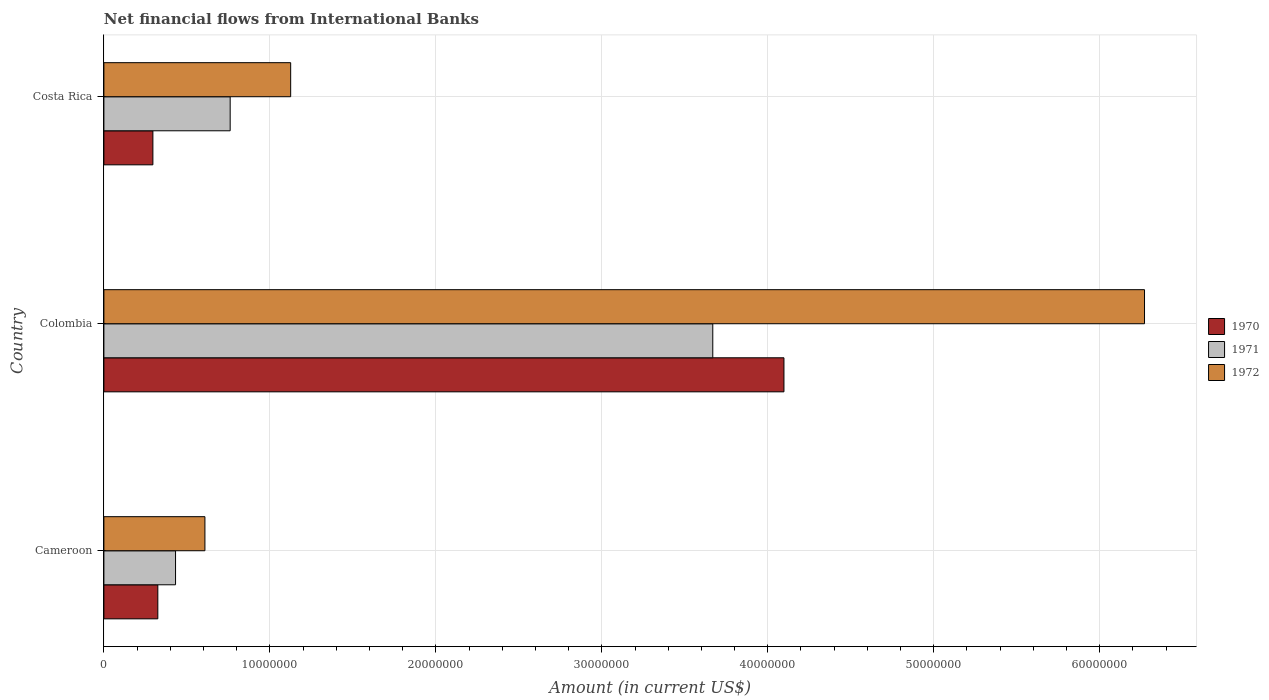How many different coloured bars are there?
Offer a terse response. 3. Are the number of bars per tick equal to the number of legend labels?
Make the answer very short. Yes. How many bars are there on the 3rd tick from the bottom?
Your response must be concise. 3. In how many cases, is the number of bars for a given country not equal to the number of legend labels?
Keep it short and to the point. 0. What is the net financial aid flows in 1972 in Cameroon?
Your answer should be compact. 6.09e+06. Across all countries, what is the maximum net financial aid flows in 1970?
Your answer should be very brief. 4.10e+07. Across all countries, what is the minimum net financial aid flows in 1972?
Your answer should be very brief. 6.09e+06. In which country was the net financial aid flows in 1970 maximum?
Your response must be concise. Colombia. In which country was the net financial aid flows in 1972 minimum?
Provide a succinct answer. Cameroon. What is the total net financial aid flows in 1971 in the graph?
Make the answer very short. 4.86e+07. What is the difference between the net financial aid flows in 1972 in Cameroon and that in Costa Rica?
Your response must be concise. -5.17e+06. What is the difference between the net financial aid flows in 1970 in Costa Rica and the net financial aid flows in 1971 in Colombia?
Give a very brief answer. -3.37e+07. What is the average net financial aid flows in 1972 per country?
Ensure brevity in your answer.  2.67e+07. What is the difference between the net financial aid flows in 1971 and net financial aid flows in 1972 in Costa Rica?
Ensure brevity in your answer.  -3.64e+06. What is the ratio of the net financial aid flows in 1970 in Colombia to that in Costa Rica?
Provide a succinct answer. 13.88. Is the net financial aid flows in 1971 in Colombia less than that in Costa Rica?
Keep it short and to the point. No. What is the difference between the highest and the second highest net financial aid flows in 1972?
Offer a terse response. 5.14e+07. What is the difference between the highest and the lowest net financial aid flows in 1971?
Offer a very short reply. 3.24e+07. In how many countries, is the net financial aid flows in 1972 greater than the average net financial aid flows in 1972 taken over all countries?
Give a very brief answer. 1. Is the sum of the net financial aid flows in 1972 in Cameroon and Costa Rica greater than the maximum net financial aid flows in 1971 across all countries?
Your response must be concise. No. How many bars are there?
Ensure brevity in your answer.  9. Are all the bars in the graph horizontal?
Provide a succinct answer. Yes. What is the difference between two consecutive major ticks on the X-axis?
Give a very brief answer. 1.00e+07. Are the values on the major ticks of X-axis written in scientific E-notation?
Give a very brief answer. No. Does the graph contain any zero values?
Your response must be concise. No. Does the graph contain grids?
Provide a succinct answer. Yes. What is the title of the graph?
Provide a succinct answer. Net financial flows from International Banks. What is the label or title of the X-axis?
Provide a succinct answer. Amount (in current US$). What is the label or title of the Y-axis?
Your answer should be very brief. Country. What is the Amount (in current US$) in 1970 in Cameroon?
Your response must be concise. 3.25e+06. What is the Amount (in current US$) in 1971 in Cameroon?
Make the answer very short. 4.32e+06. What is the Amount (in current US$) in 1972 in Cameroon?
Give a very brief answer. 6.09e+06. What is the Amount (in current US$) in 1970 in Colombia?
Offer a very short reply. 4.10e+07. What is the Amount (in current US$) in 1971 in Colombia?
Give a very brief answer. 3.67e+07. What is the Amount (in current US$) of 1972 in Colombia?
Provide a short and direct response. 6.27e+07. What is the Amount (in current US$) of 1970 in Costa Rica?
Your answer should be very brief. 2.95e+06. What is the Amount (in current US$) of 1971 in Costa Rica?
Keep it short and to the point. 7.61e+06. What is the Amount (in current US$) in 1972 in Costa Rica?
Keep it short and to the point. 1.13e+07. Across all countries, what is the maximum Amount (in current US$) of 1970?
Offer a terse response. 4.10e+07. Across all countries, what is the maximum Amount (in current US$) of 1971?
Offer a terse response. 3.67e+07. Across all countries, what is the maximum Amount (in current US$) of 1972?
Offer a very short reply. 6.27e+07. Across all countries, what is the minimum Amount (in current US$) in 1970?
Provide a succinct answer. 2.95e+06. Across all countries, what is the minimum Amount (in current US$) in 1971?
Give a very brief answer. 4.32e+06. Across all countries, what is the minimum Amount (in current US$) in 1972?
Your response must be concise. 6.09e+06. What is the total Amount (in current US$) of 1970 in the graph?
Your response must be concise. 4.72e+07. What is the total Amount (in current US$) in 1971 in the graph?
Ensure brevity in your answer.  4.86e+07. What is the total Amount (in current US$) in 1972 in the graph?
Give a very brief answer. 8.00e+07. What is the difference between the Amount (in current US$) of 1970 in Cameroon and that in Colombia?
Your answer should be compact. -3.77e+07. What is the difference between the Amount (in current US$) of 1971 in Cameroon and that in Colombia?
Your response must be concise. -3.24e+07. What is the difference between the Amount (in current US$) in 1972 in Cameroon and that in Colombia?
Ensure brevity in your answer.  -5.66e+07. What is the difference between the Amount (in current US$) in 1970 in Cameroon and that in Costa Rica?
Keep it short and to the point. 2.98e+05. What is the difference between the Amount (in current US$) of 1971 in Cameroon and that in Costa Rica?
Provide a succinct answer. -3.29e+06. What is the difference between the Amount (in current US$) of 1972 in Cameroon and that in Costa Rica?
Provide a succinct answer. -5.17e+06. What is the difference between the Amount (in current US$) in 1970 in Colombia and that in Costa Rica?
Provide a short and direct response. 3.80e+07. What is the difference between the Amount (in current US$) of 1971 in Colombia and that in Costa Rica?
Your answer should be compact. 2.91e+07. What is the difference between the Amount (in current US$) of 1972 in Colombia and that in Costa Rica?
Keep it short and to the point. 5.14e+07. What is the difference between the Amount (in current US$) of 1970 in Cameroon and the Amount (in current US$) of 1971 in Colombia?
Make the answer very short. -3.34e+07. What is the difference between the Amount (in current US$) of 1970 in Cameroon and the Amount (in current US$) of 1972 in Colombia?
Offer a very short reply. -5.94e+07. What is the difference between the Amount (in current US$) in 1971 in Cameroon and the Amount (in current US$) in 1972 in Colombia?
Make the answer very short. -5.84e+07. What is the difference between the Amount (in current US$) in 1970 in Cameroon and the Amount (in current US$) in 1971 in Costa Rica?
Offer a terse response. -4.36e+06. What is the difference between the Amount (in current US$) in 1970 in Cameroon and the Amount (in current US$) in 1972 in Costa Rica?
Keep it short and to the point. -8.00e+06. What is the difference between the Amount (in current US$) of 1971 in Cameroon and the Amount (in current US$) of 1972 in Costa Rica?
Ensure brevity in your answer.  -6.94e+06. What is the difference between the Amount (in current US$) of 1970 in Colombia and the Amount (in current US$) of 1971 in Costa Rica?
Offer a very short reply. 3.34e+07. What is the difference between the Amount (in current US$) of 1970 in Colombia and the Amount (in current US$) of 1972 in Costa Rica?
Make the answer very short. 2.97e+07. What is the difference between the Amount (in current US$) of 1971 in Colombia and the Amount (in current US$) of 1972 in Costa Rica?
Your answer should be very brief. 2.54e+07. What is the average Amount (in current US$) of 1970 per country?
Make the answer very short. 1.57e+07. What is the average Amount (in current US$) of 1971 per country?
Offer a terse response. 1.62e+07. What is the average Amount (in current US$) in 1972 per country?
Provide a succinct answer. 2.67e+07. What is the difference between the Amount (in current US$) in 1970 and Amount (in current US$) in 1971 in Cameroon?
Keep it short and to the point. -1.07e+06. What is the difference between the Amount (in current US$) in 1970 and Amount (in current US$) in 1972 in Cameroon?
Make the answer very short. -2.84e+06. What is the difference between the Amount (in current US$) of 1971 and Amount (in current US$) of 1972 in Cameroon?
Give a very brief answer. -1.77e+06. What is the difference between the Amount (in current US$) in 1970 and Amount (in current US$) in 1971 in Colombia?
Keep it short and to the point. 4.29e+06. What is the difference between the Amount (in current US$) of 1970 and Amount (in current US$) of 1972 in Colombia?
Provide a succinct answer. -2.17e+07. What is the difference between the Amount (in current US$) in 1971 and Amount (in current US$) in 1972 in Colombia?
Keep it short and to the point. -2.60e+07. What is the difference between the Amount (in current US$) in 1970 and Amount (in current US$) in 1971 in Costa Rica?
Make the answer very short. -4.66e+06. What is the difference between the Amount (in current US$) in 1970 and Amount (in current US$) in 1972 in Costa Rica?
Provide a succinct answer. -8.30e+06. What is the difference between the Amount (in current US$) in 1971 and Amount (in current US$) in 1972 in Costa Rica?
Ensure brevity in your answer.  -3.64e+06. What is the ratio of the Amount (in current US$) of 1970 in Cameroon to that in Colombia?
Keep it short and to the point. 0.08. What is the ratio of the Amount (in current US$) of 1971 in Cameroon to that in Colombia?
Make the answer very short. 0.12. What is the ratio of the Amount (in current US$) in 1972 in Cameroon to that in Colombia?
Ensure brevity in your answer.  0.1. What is the ratio of the Amount (in current US$) in 1970 in Cameroon to that in Costa Rica?
Your response must be concise. 1.1. What is the ratio of the Amount (in current US$) in 1971 in Cameroon to that in Costa Rica?
Your answer should be compact. 0.57. What is the ratio of the Amount (in current US$) of 1972 in Cameroon to that in Costa Rica?
Provide a succinct answer. 0.54. What is the ratio of the Amount (in current US$) of 1970 in Colombia to that in Costa Rica?
Give a very brief answer. 13.88. What is the ratio of the Amount (in current US$) of 1971 in Colombia to that in Costa Rica?
Give a very brief answer. 4.82. What is the ratio of the Amount (in current US$) of 1972 in Colombia to that in Costa Rica?
Keep it short and to the point. 5.57. What is the difference between the highest and the second highest Amount (in current US$) in 1970?
Give a very brief answer. 3.77e+07. What is the difference between the highest and the second highest Amount (in current US$) in 1971?
Make the answer very short. 2.91e+07. What is the difference between the highest and the second highest Amount (in current US$) of 1972?
Your response must be concise. 5.14e+07. What is the difference between the highest and the lowest Amount (in current US$) in 1970?
Keep it short and to the point. 3.80e+07. What is the difference between the highest and the lowest Amount (in current US$) in 1971?
Your response must be concise. 3.24e+07. What is the difference between the highest and the lowest Amount (in current US$) of 1972?
Your answer should be very brief. 5.66e+07. 